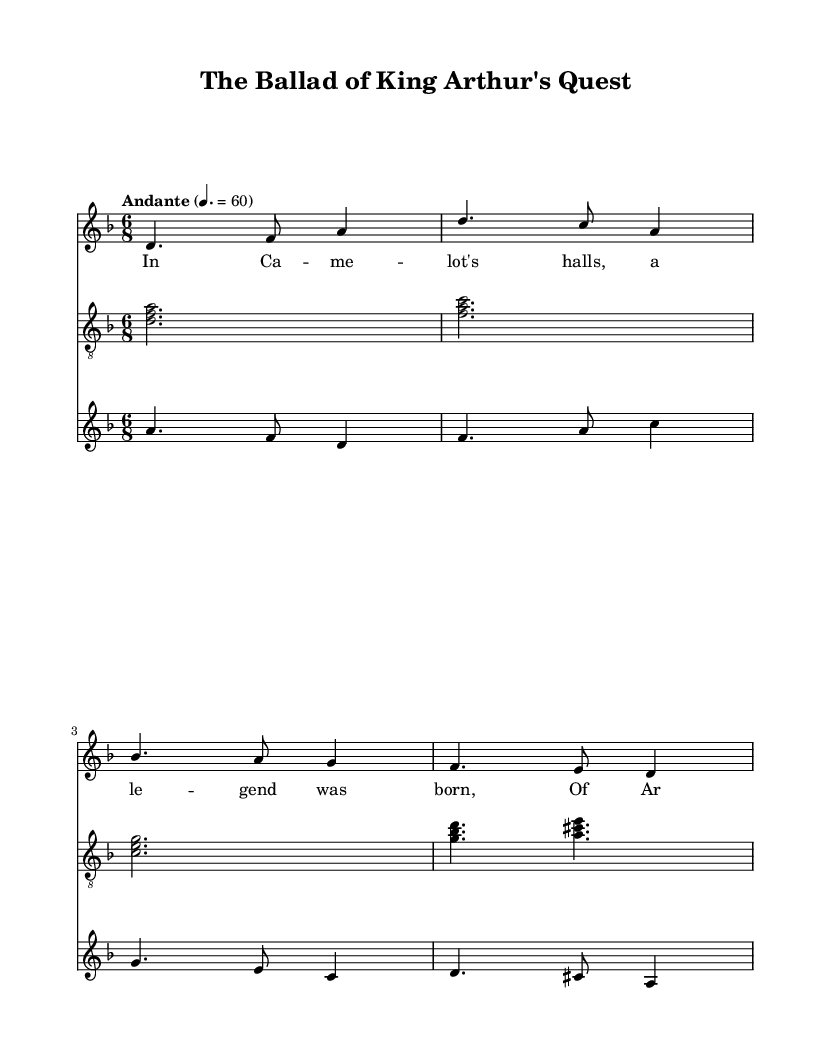What is the key signature of this music? The key signature is indicated by the sharps or flats at the beginning of the staff. The presence of a B flat indicates that this piece is in D minor, which has one flat.
Answer: D minor What is the time signature of the piece? The time signature is displayed at the beginning of the sheet music. Here, it is shown as 6/8, which means there are six eighth notes per measure.
Answer: 6/8 What is the tempo marking of the piece? The tempo marking is usually indicated above the staff. In this case, it states "Andante" with a metronome marking of 60, signifying a moderate pace.
Answer: Andante Which instrument plays the melody? The melody is typically carried by the first staff in the score, which shows a voice with lyrics. Thus, this indicates that the voice is responsible for the melody.
Answer: Voice What is the primary theme or subject of the lyrics? The lyrics mention "Camelot" and "Arthur," suggesting a recounting of a medieval legend about King Arthur, specifically his legendary sword Excalibur. This context leads us to understand the theme.
Answer: King Arthur How many notes are in the first measure of the melody? By counting the notes in the first measure, we see there are four notes present: D, F, A, and the following subdivisions. Counting these visually: D (sustained), F, A, and then the ties indicate the phrasing.
Answer: 4 What is the name of the ballad represented in this sheet music? The title is presented in the header of the score, which states "The Ballad of King Arthur's Quest," indicating the specific folk ballad being represented.
Answer: The Ballad of King Arthur's Quest 